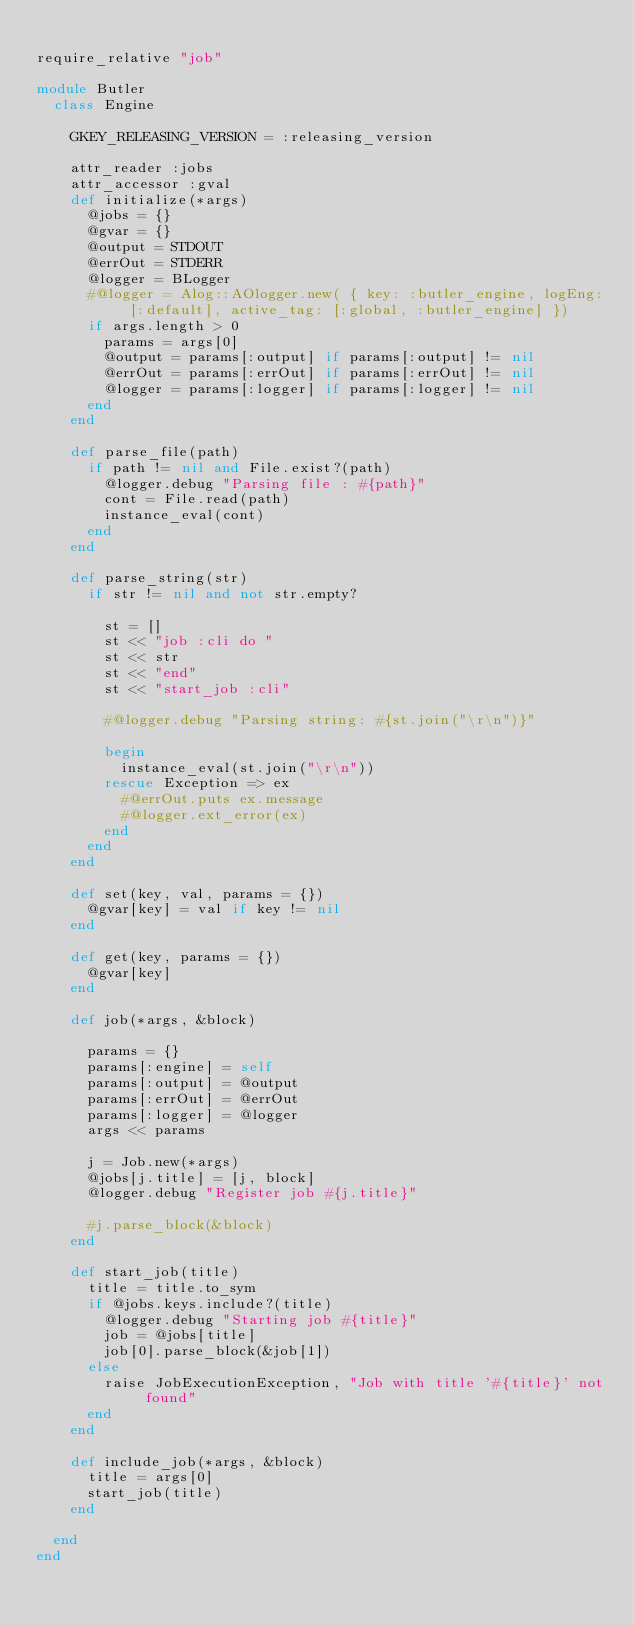<code> <loc_0><loc_0><loc_500><loc_500><_Ruby_>
require_relative "job"

module Butler
  class Engine

    GKEY_RELEASING_VERSION = :releasing_version
    
    attr_reader :jobs
    attr_accessor :gval
    def initialize(*args)
      @jobs = {}
      @gvar = {}
      @output = STDOUT
      @errOut = STDERR
      @logger = BLogger
      #@logger = Alog::AOlogger.new( { key: :butler_engine, logEng: [:default], active_tag: [:global, :butler_engine] }) 
      if args.length > 0
        params = args[0]
        @output = params[:output] if params[:output] != nil
        @errOut = params[:errOut] if params[:errOut] != nil
        @logger = params[:logger] if params[:logger] != nil
      end
    end

    def parse_file(path)
      if path != nil and File.exist?(path)
        @logger.debug "Parsing file : #{path}"
        cont = File.read(path)
        instance_eval(cont)
      end
    end

    def parse_string(str)
      if str != nil and not str.empty?

        st = []
        st << "job :cli do "
        st << str
        st << "end"
        st << "start_job :cli"
        
        #@logger.debug "Parsing string: #{st.join("\r\n")}"
        
        begin
          instance_eval(st.join("\r\n"))
        rescue Exception => ex
          #@errOut.puts ex.message
          #@logger.ext_error(ex)
        end
      end
    end
    
    def set(key, val, params = {})
      @gvar[key] = val if key != nil
    end

    def get(key, params = {})
      @gvar[key]
    end

    def job(*args, &block)
     
      params = {}
      params[:engine] = self
      params[:output] = @output
      params[:errOut] = @errOut
      params[:logger] = @logger
      args << params
      
      j = Job.new(*args)
      @jobs[j.title] = [j, block]
      @logger.debug "Register job #{j.title}"
      
      #j.parse_block(&block)
    end

    def start_job(title)
      title = title.to_sym
      if @jobs.keys.include?(title)
        @logger.debug "Starting job #{title}"
        job = @jobs[title]
        job[0].parse_block(&job[1])
      else
        raise JobExecutionException, "Job with title '#{title}' not found"
      end
    end

    def include_job(*args, &block)
      title = args[0]
      start_job(title)
    end

  end
end
</code> 